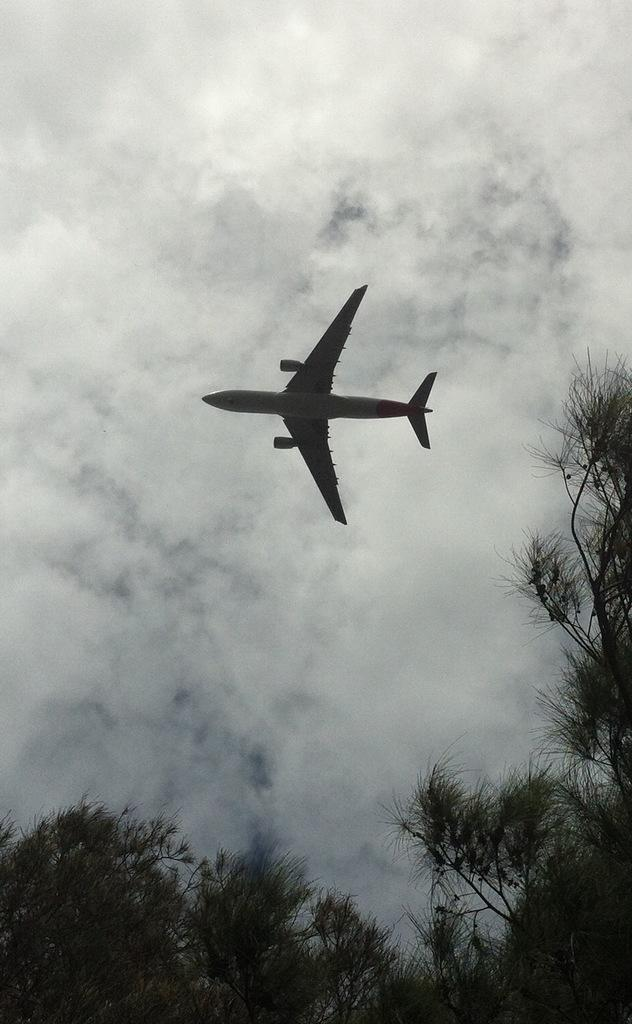What type of vegetation is present on the ground in the image? There are trees on the ground in the image. What is flying in the air in the image? An airplane is flying in the air in the image. What can be seen in the sky in the background of the image? There are clouds in the sky in the background of the image. How many frogs are sitting on the rock in the image? There is no rock or frogs present in the image. What type of test is being conducted in the image? There is no test being conducted in the image; it features trees, an airplane, and clouds. 